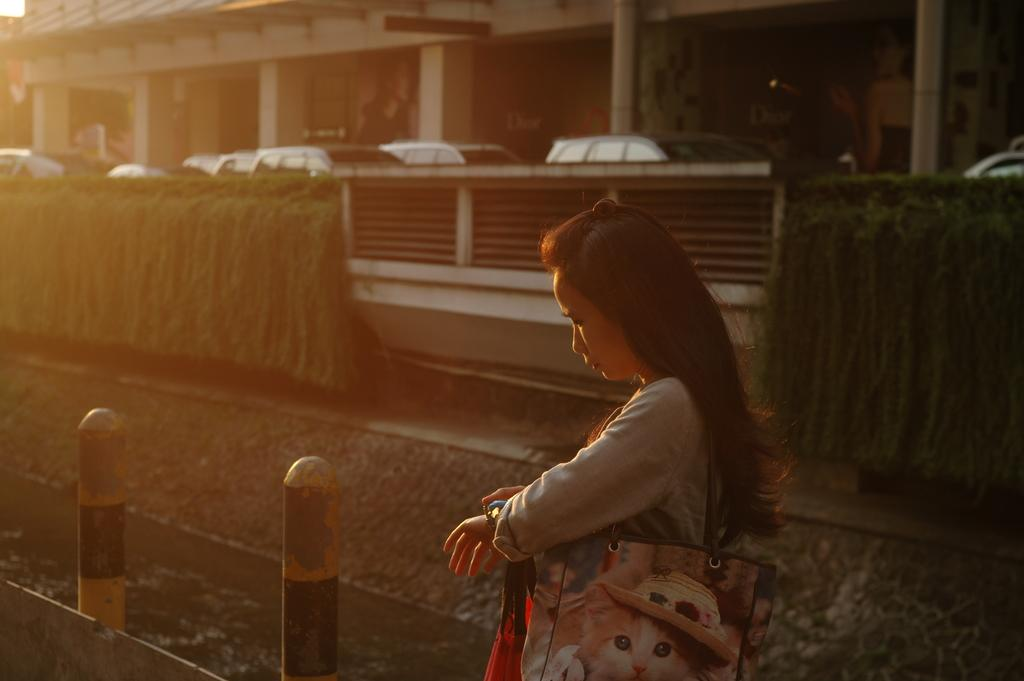Who is the main subject in the image? There is a woman standing in the front of the image. What is the woman holding in the image? The woman is holding a bag. What can be seen in the background of the image? There are poles, plants, cars, and a building in the background of the image. What type of suit is the woman wearing in the image? There is no mention of a suit in the image; the woman is simply standing and holding a bag. 